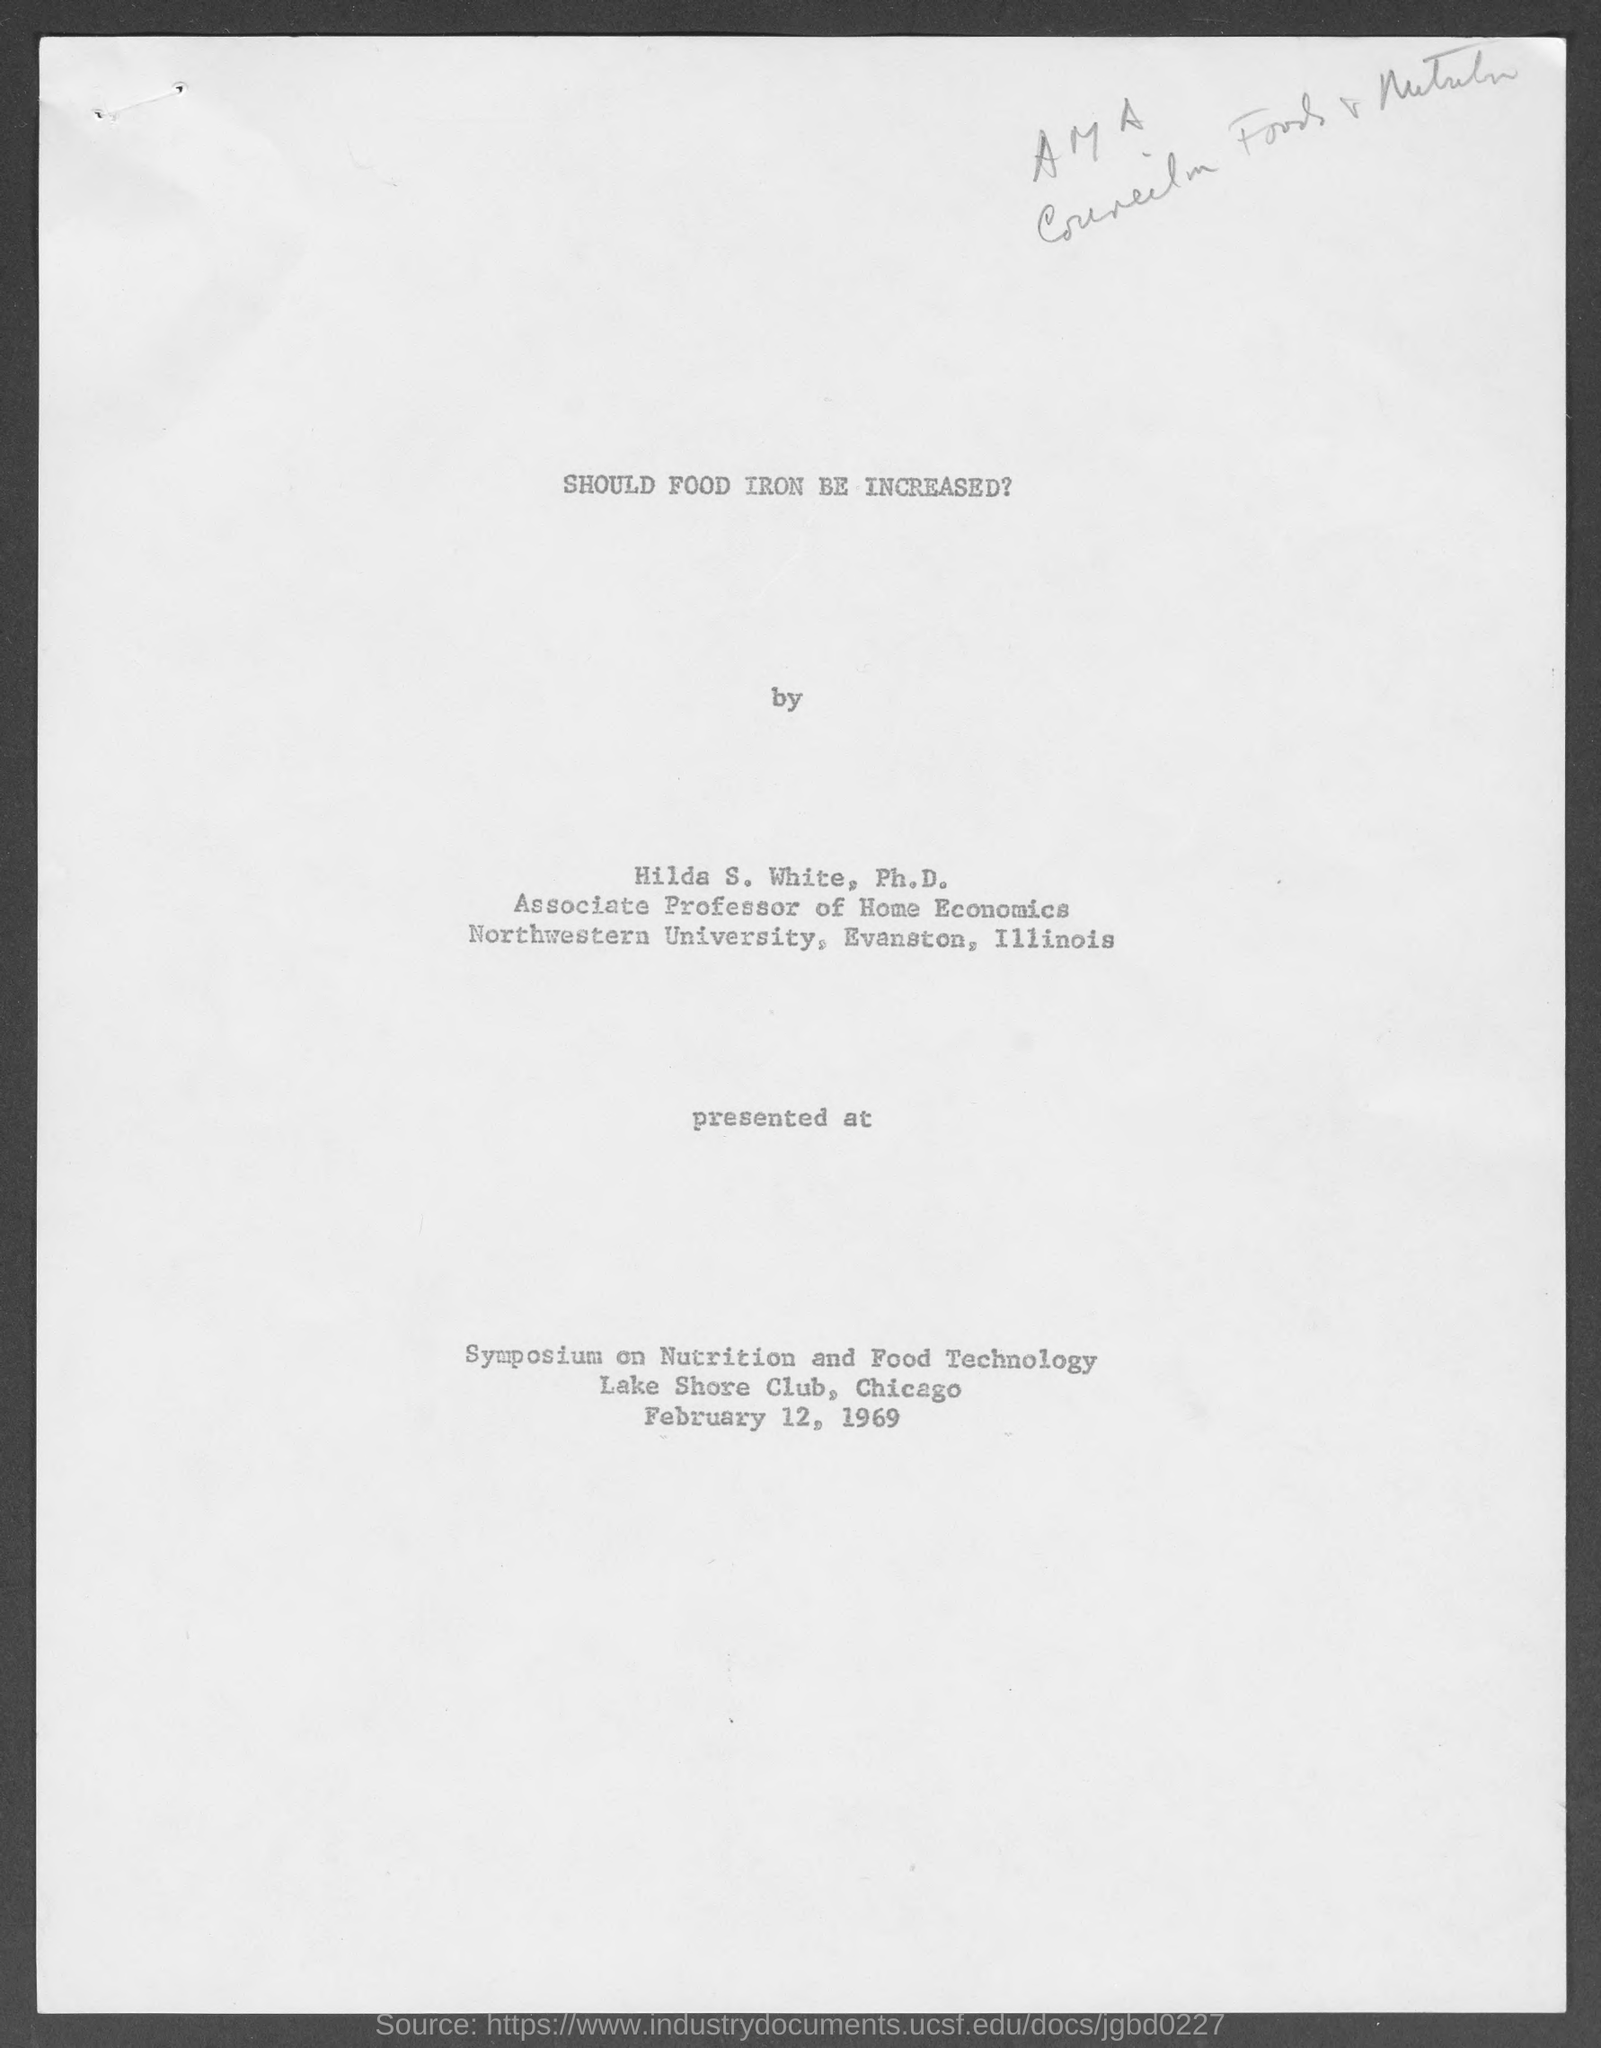Indicate a few pertinent items in this graphic. The Symposium on Nutrition and Food Technology was held at the Lake Shore Club in Chicago. The Symposium on Nutrition and Food Technology was held on February 12, 1969. 